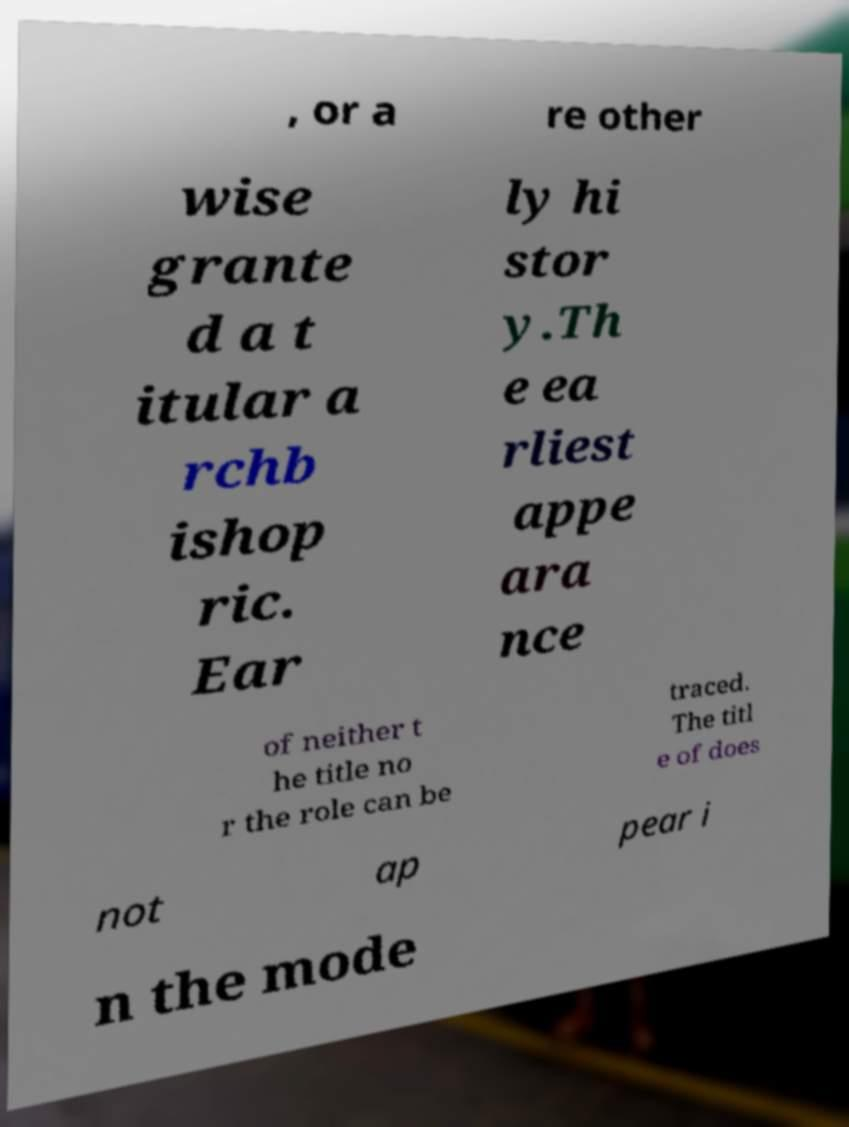Please read and relay the text visible in this image. What does it say? , or a re other wise grante d a t itular a rchb ishop ric. Ear ly hi stor y.Th e ea rliest appe ara nce of neither t he title no r the role can be traced. The titl e of does not ap pear i n the mode 